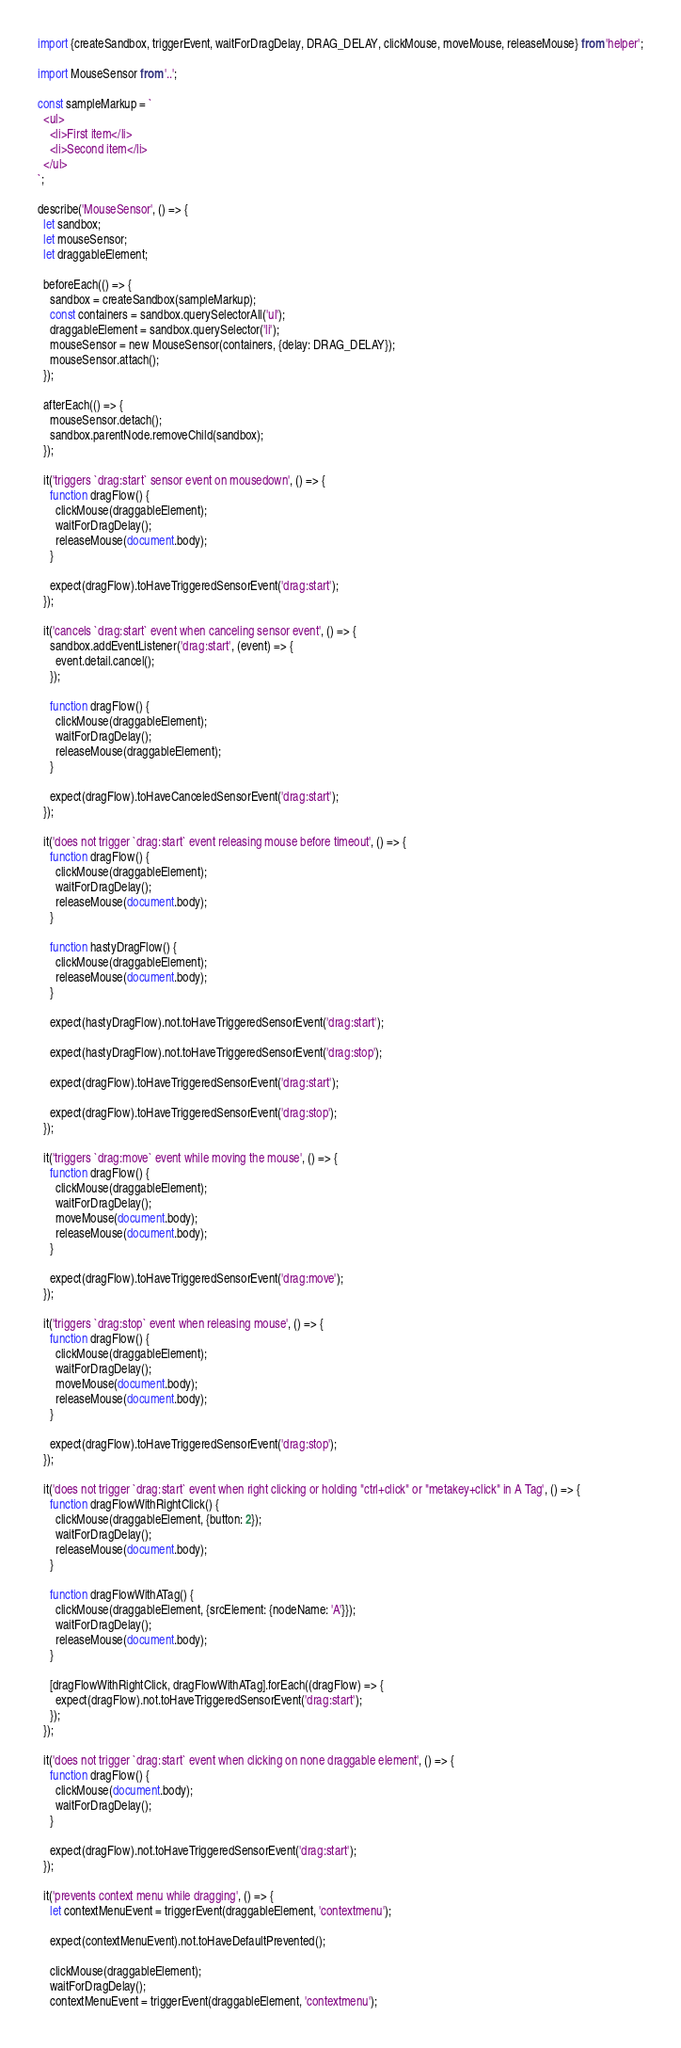Convert code to text. <code><loc_0><loc_0><loc_500><loc_500><_JavaScript_>import {createSandbox, triggerEvent, waitForDragDelay, DRAG_DELAY, clickMouse, moveMouse, releaseMouse} from 'helper';

import MouseSensor from '..';

const sampleMarkup = `
  <ul>
    <li>First item</li>
    <li>Second item</li>
  </ul>
`;

describe('MouseSensor', () => {
  let sandbox;
  let mouseSensor;
  let draggableElement;

  beforeEach(() => {
    sandbox = createSandbox(sampleMarkup);
    const containers = sandbox.querySelectorAll('ul');
    draggableElement = sandbox.querySelector('li');
    mouseSensor = new MouseSensor(containers, {delay: DRAG_DELAY});
    mouseSensor.attach();
  });

  afterEach(() => {
    mouseSensor.detach();
    sandbox.parentNode.removeChild(sandbox);
  });

  it('triggers `drag:start` sensor event on mousedown', () => {
    function dragFlow() {
      clickMouse(draggableElement);
      waitForDragDelay();
      releaseMouse(document.body);
    }

    expect(dragFlow).toHaveTriggeredSensorEvent('drag:start');
  });

  it('cancels `drag:start` event when canceling sensor event', () => {
    sandbox.addEventListener('drag:start', (event) => {
      event.detail.cancel();
    });

    function dragFlow() {
      clickMouse(draggableElement);
      waitForDragDelay();
      releaseMouse(draggableElement);
    }

    expect(dragFlow).toHaveCanceledSensorEvent('drag:start');
  });

  it('does not trigger `drag:start` event releasing mouse before timeout', () => {
    function dragFlow() {
      clickMouse(draggableElement);
      waitForDragDelay();
      releaseMouse(document.body);
    }

    function hastyDragFlow() {
      clickMouse(draggableElement);
      releaseMouse(document.body);
    }

    expect(hastyDragFlow).not.toHaveTriggeredSensorEvent('drag:start');

    expect(hastyDragFlow).not.toHaveTriggeredSensorEvent('drag:stop');

    expect(dragFlow).toHaveTriggeredSensorEvent('drag:start');

    expect(dragFlow).toHaveTriggeredSensorEvent('drag:stop');
  });

  it('triggers `drag:move` event while moving the mouse', () => {
    function dragFlow() {
      clickMouse(draggableElement);
      waitForDragDelay();
      moveMouse(document.body);
      releaseMouse(document.body);
    }

    expect(dragFlow).toHaveTriggeredSensorEvent('drag:move');
  });

  it('triggers `drag:stop` event when releasing mouse', () => {
    function dragFlow() {
      clickMouse(draggableElement);
      waitForDragDelay();
      moveMouse(document.body);
      releaseMouse(document.body);
    }

    expect(dragFlow).toHaveTriggeredSensorEvent('drag:stop');
  });

  it('does not trigger `drag:start` event when right clicking or holding "ctrl+click" or "metakey+click" in A Tag', () => {
    function dragFlowWithRightClick() {
      clickMouse(draggableElement, {button: 2});
      waitForDragDelay();
      releaseMouse(document.body);
    }

    function dragFlowWithATag() {
      clickMouse(draggableElement, {srcElement: {nodeName: 'A'}});
      waitForDragDelay();
      releaseMouse(document.body);
    }

    [dragFlowWithRightClick, dragFlowWithATag].forEach((dragFlow) => {
      expect(dragFlow).not.toHaveTriggeredSensorEvent('drag:start');
    });
  });

  it('does not trigger `drag:start` event when clicking on none draggable element', () => {
    function dragFlow() {
      clickMouse(document.body);
      waitForDragDelay();
    }

    expect(dragFlow).not.toHaveTriggeredSensorEvent('drag:start');
  });

  it('prevents context menu while dragging', () => {
    let contextMenuEvent = triggerEvent(draggableElement, 'contextmenu');

    expect(contextMenuEvent).not.toHaveDefaultPrevented();

    clickMouse(draggableElement);
    waitForDragDelay();
    contextMenuEvent = triggerEvent(draggableElement, 'contextmenu');
</code> 